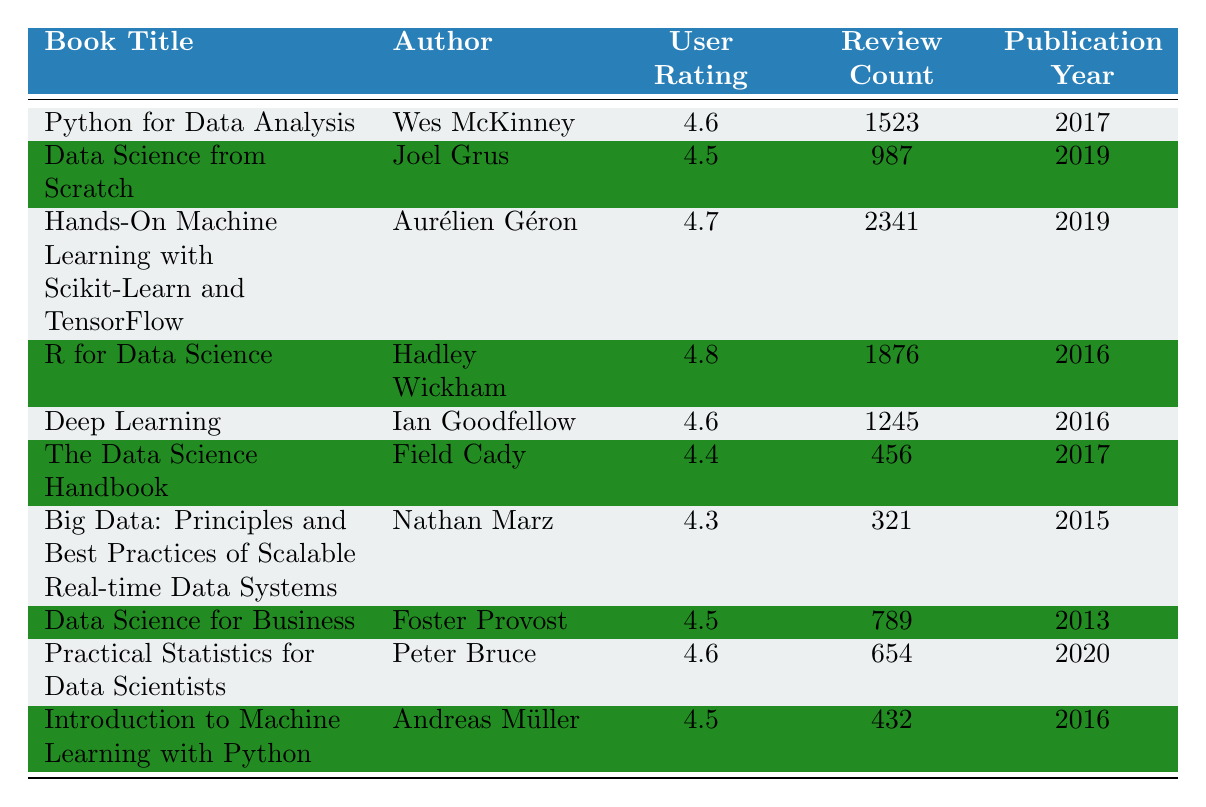What is the user rating of "R for Data Science"? The table shows that the user rating for "R for Data Science" is 4.8.
Answer: 4.8 Who is the author of "Deep Learning"? According to the table, the author of "Deep Learning" is Ian Goodfellow.
Answer: Ian Goodfellow What is the review count for "Practical Statistics for Data Scientists"? The table indicates that "Practical Statistics for Data Scientists" has a review count of 654.
Answer: 654 Which book has the highest user rating? By comparing all user ratings in the table, "R for Data Science" has the highest rating of 4.8.
Answer: "R for Data Science" How many books have a user rating of 4.6? The books with a user rating of 4.6 are: "Python for Data Analysis," "Deep Learning," and "Practical Statistics for Data Scientists." There are three books in total.
Answer: 3 What is the average user rating of the books published in 2019? The books published in 2019 are "Data Science from Scratch" and "Hands-On Machine Learning with Scikit-Learn and TensorFlow." Their ratings are 4.5 and 4.7, respectively. The average is (4.5 + 4.7) / 2 = 4.6.
Answer: 4.6 Is "Data Science for Business" rated higher than "Big Data: Principles and Best Practices of Scalable Real-time Data Systems"? The user rating for "Data Science for Business" is 4.5, while "Big Data" has a rating of 4.3. Since 4.5 is greater than 4.3, the statement is true.
Answer: Yes Which book has the lowest review count? The book with the lowest review count in the table is "The Data Science Handbook" with 456 reviews.
Answer: "The Data Science Handbook" If we only consider books published after 2016, what is the total review count? The books published after 2016 are "Data Science from Scratch" (987), "Hands-On Machine Learning with Scikit-Learn and TensorFlow" (2341), "Practical Statistics for Data Scientists" (654). The total review count is 987 + 2341 + 654 = 3982.
Answer: 3982 Which author has the most books listed in the table? Checking the author names, no author appears more than once in the table. So, none have multiple books listed.
Answer: None 